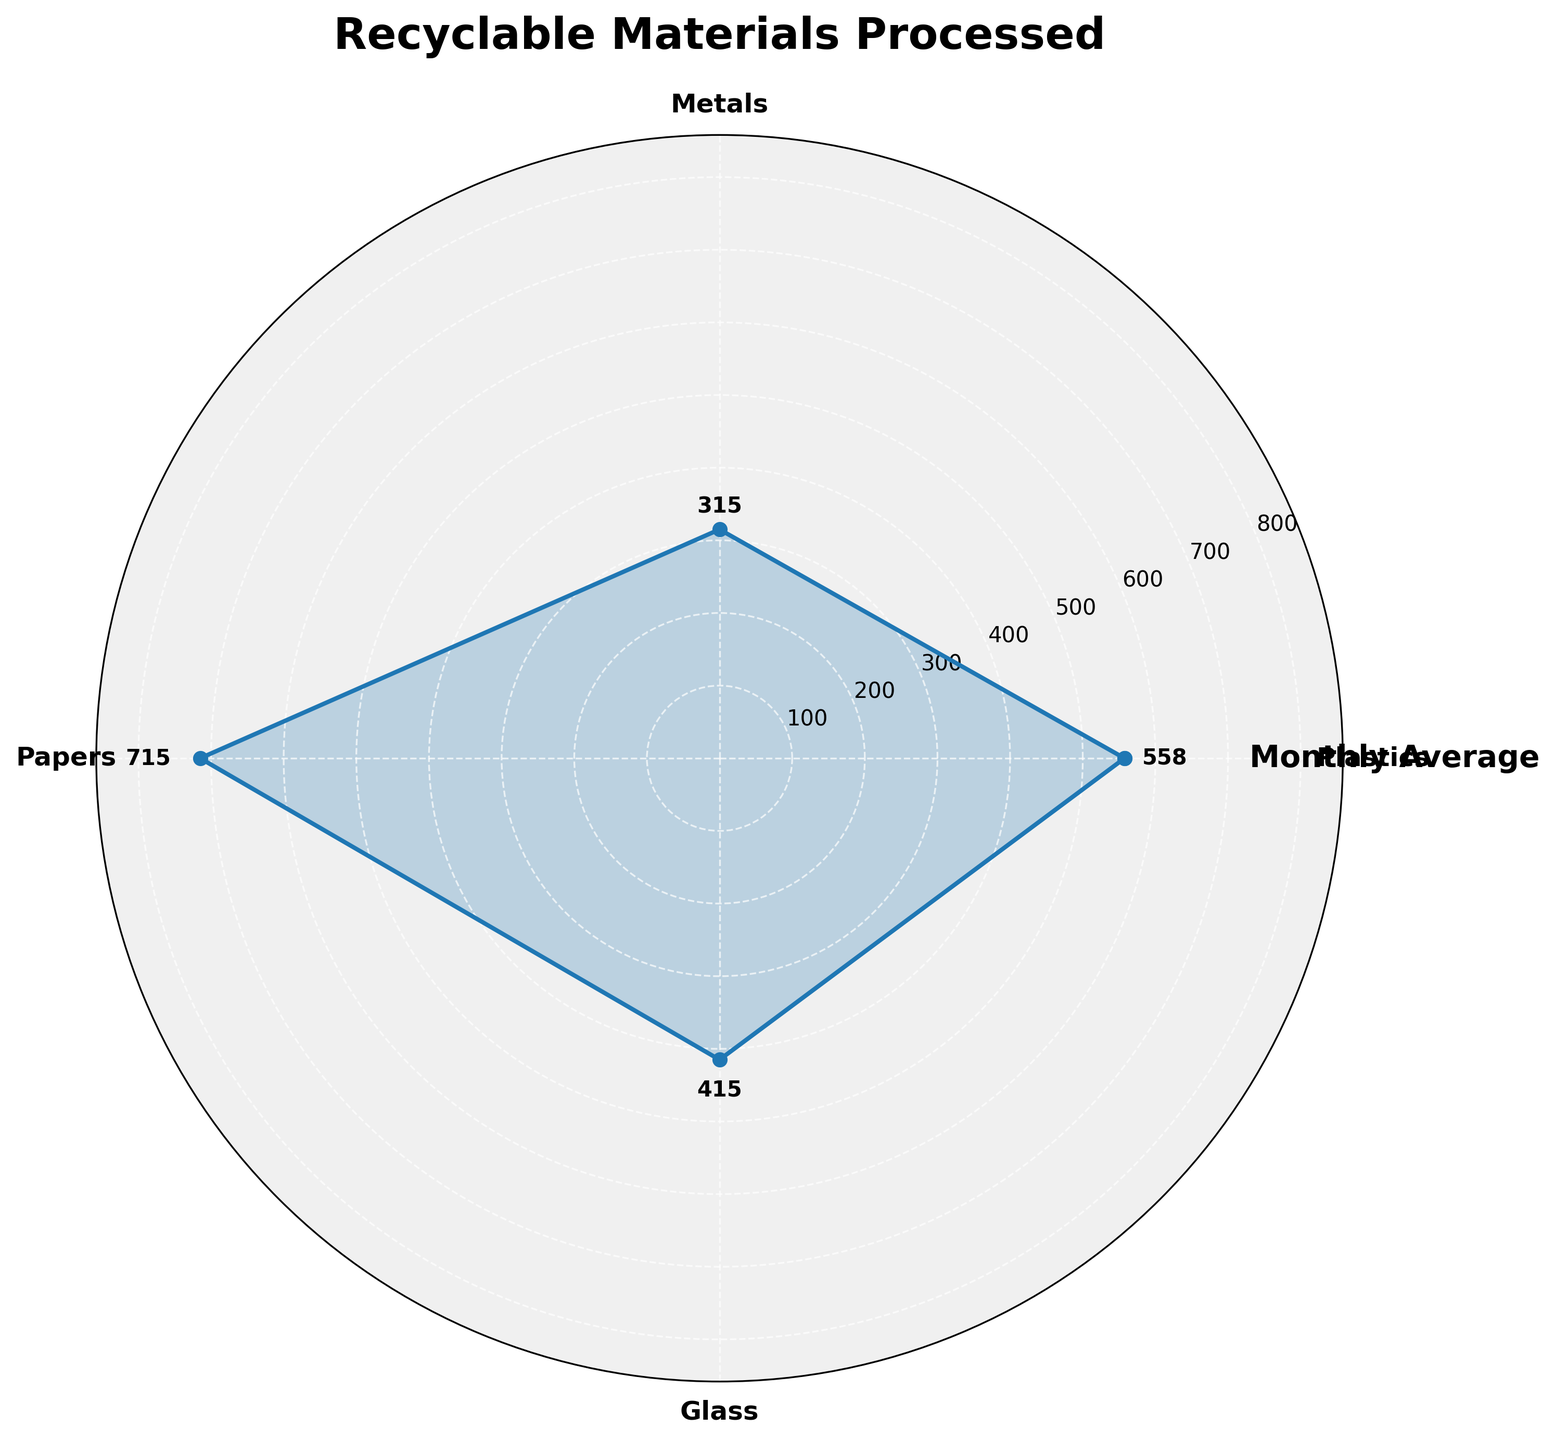what is the title of the plot? The title of the plot is displayed at the top of the chart in bold, saying "Recyclable Materials Processed".
Answer: Recyclable Materials Processed How many different types of recyclable materials are shown in the plot? The plot shows different types of recyclable materials by distinct sections marked along the angular axis. Counting them reveals four types: Plastics, Metals, Papers, and Glass.
Answer: Four Which recyclable material is processed the most on average? By looking at the radial extent of each material, the material with the greatest distance from the center represents the highest average processed value. In this case, it is Papers.
Answer: Papers Which material shows the smallest average processing value? The radial extent of each material shows the average processing value, and the smallest distance from the center corresponds to Metals.
Answer: Metals What is the average amount of glass processed over the month? The value mark on the radial extent shows around 415, this is the average value for glass over the month considering angles and marked values.
Answer: 415 Which material has a higher average processing amount, plastics or glass? Comparing the radial values of Plastics and Glass, Plastics with an average of 557.5 is higher than Glass with an average of 415.
Answer: Plastics What is the difference in the average amount processed between plastics and metals? The average values for Plastics and Metals are approximately 557.5 and 315 respectively. Subtracting Metals from Plastics gives a difference of 242.5.
Answer: 242.5 